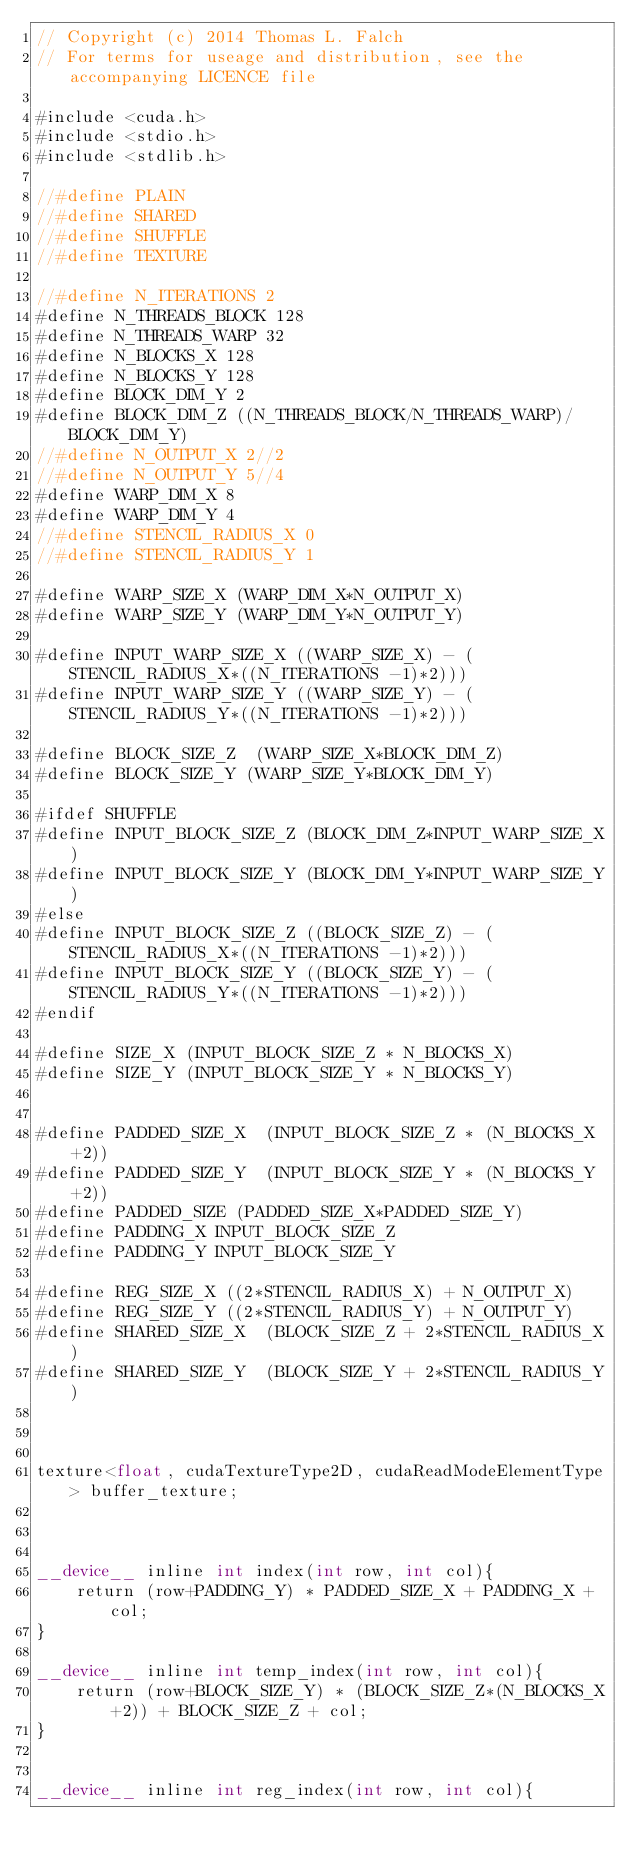Convert code to text. <code><loc_0><loc_0><loc_500><loc_500><_Cuda_>// Copyright (c) 2014 Thomas L. Falch
// For terms for useage and distribution, see the accompanying LICENCE file

#include <cuda.h>
#include <stdio.h>
#include <stdlib.h>

//#define PLAIN
//#define SHARED
//#define SHUFFLE
//#define TEXTURE

//#define N_ITERATIONS 2
#define N_THREADS_BLOCK 128
#define N_THREADS_WARP 32
#define N_BLOCKS_X 128
#define N_BLOCKS_Y 128
#define BLOCK_DIM_Y 2
#define BLOCK_DIM_Z ((N_THREADS_BLOCK/N_THREADS_WARP)/BLOCK_DIM_Y)
//#define N_OUTPUT_X 2//2
//#define N_OUTPUT_Y 5//4
#define WARP_DIM_X 8
#define WARP_DIM_Y 4
//#define STENCIL_RADIUS_X 0
//#define STENCIL_RADIUS_Y 1

#define WARP_SIZE_X (WARP_DIM_X*N_OUTPUT_X)
#define WARP_SIZE_Y (WARP_DIM_Y*N_OUTPUT_Y)

#define INPUT_WARP_SIZE_X ((WARP_SIZE_X) - (STENCIL_RADIUS_X*((N_ITERATIONS -1)*2)))
#define INPUT_WARP_SIZE_Y ((WARP_SIZE_Y) - (STENCIL_RADIUS_Y*((N_ITERATIONS -1)*2)))

#define BLOCK_SIZE_Z  (WARP_SIZE_X*BLOCK_DIM_Z)
#define BLOCK_SIZE_Y (WARP_SIZE_Y*BLOCK_DIM_Y)

#ifdef SHUFFLE
#define INPUT_BLOCK_SIZE_Z (BLOCK_DIM_Z*INPUT_WARP_SIZE_X)
#define INPUT_BLOCK_SIZE_Y (BLOCK_DIM_Y*INPUT_WARP_SIZE_Y)
#else
#define INPUT_BLOCK_SIZE_Z ((BLOCK_SIZE_Z) - (STENCIL_RADIUS_X*((N_ITERATIONS -1)*2)))
#define INPUT_BLOCK_SIZE_Y ((BLOCK_SIZE_Y) - (STENCIL_RADIUS_Y*((N_ITERATIONS -1)*2)))
#endif

#define SIZE_X (INPUT_BLOCK_SIZE_Z * N_BLOCKS_X)
#define SIZE_Y (INPUT_BLOCK_SIZE_Y * N_BLOCKS_Y)


#define PADDED_SIZE_X  (INPUT_BLOCK_SIZE_Z * (N_BLOCKS_X+2))
#define PADDED_SIZE_Y  (INPUT_BLOCK_SIZE_Y * (N_BLOCKS_Y+2))
#define PADDED_SIZE (PADDED_SIZE_X*PADDED_SIZE_Y)
#define PADDING_X INPUT_BLOCK_SIZE_Z
#define PADDING_Y INPUT_BLOCK_SIZE_Y

#define REG_SIZE_X ((2*STENCIL_RADIUS_X) + N_OUTPUT_X)
#define REG_SIZE_Y ((2*STENCIL_RADIUS_Y) + N_OUTPUT_Y)
#define SHARED_SIZE_X  (BLOCK_SIZE_Z + 2*STENCIL_RADIUS_X)
#define SHARED_SIZE_Y  (BLOCK_SIZE_Y + 2*STENCIL_RADIUS_Y)



texture<float, cudaTextureType2D, cudaReadModeElementType> buffer_texture;



__device__ inline int index(int row, int col){
	return (row+PADDING_Y) * PADDED_SIZE_X + PADDING_X + col;
}

__device__ inline int temp_index(int row, int col){
	return (row+BLOCK_SIZE_Y) * (BLOCK_SIZE_Z*(N_BLOCKS_X+2)) + BLOCK_SIZE_Z + col;
}


__device__ inline int reg_index(int row, int col){</code> 